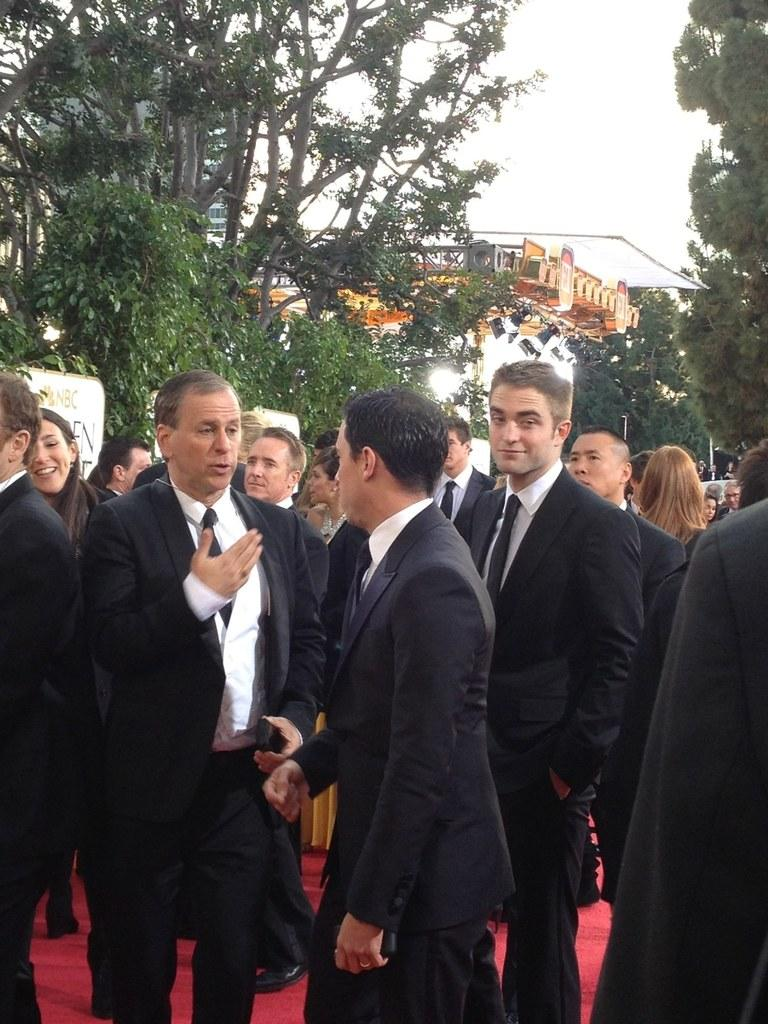How many people are in the group visible in the image? There is a group of people standing in the image, but the exact number cannot be determined from the provided facts. What type of vegetation is present in the image? There are trees in the image. What type of lighting is present in the image? Focus lights are present in the image. What type of structure is visible in the image? A truss is visible in the image. What is visible in the background of the image? The sky and a building behind the trees are visible in the background of the image. What type of zephyr is blowing through the stocking of the person in the image? There is no mention of a zephyr or stocking in the image, so this question cannot be answered. How many roses are being held by the person in the image? There is no person holding a rose in the image, so this question cannot be answered. 